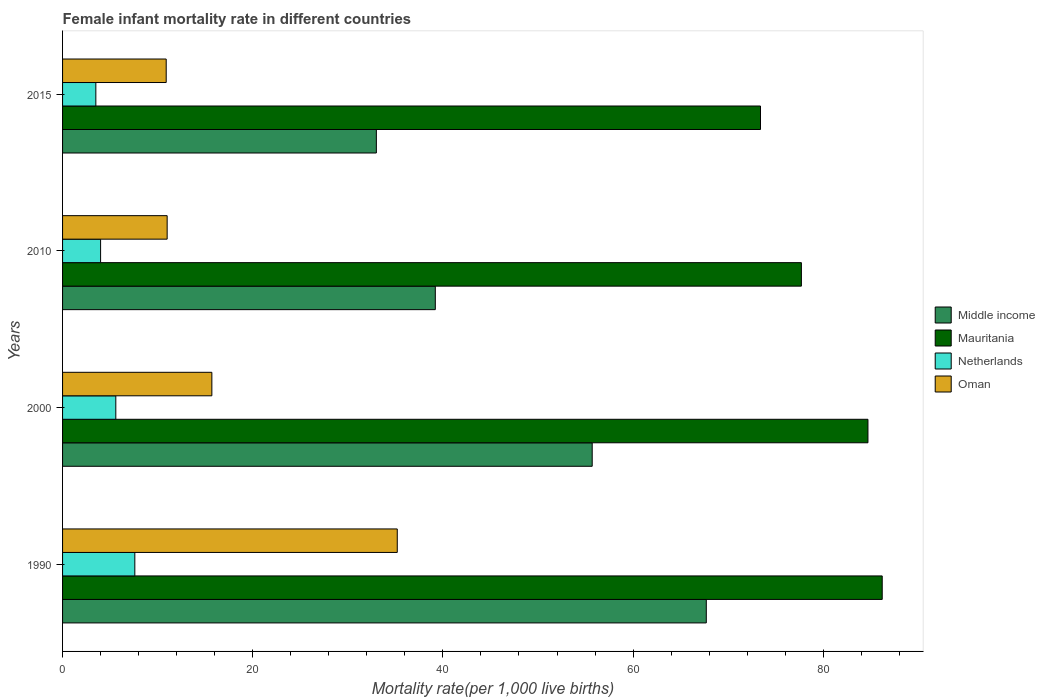How many different coloured bars are there?
Give a very brief answer. 4. How many groups of bars are there?
Your answer should be very brief. 4. Are the number of bars per tick equal to the number of legend labels?
Your answer should be very brief. Yes. Are the number of bars on each tick of the Y-axis equal?
Make the answer very short. Yes. How many bars are there on the 2nd tick from the bottom?
Make the answer very short. 4. Across all years, what is the minimum female infant mortality rate in Mauritania?
Provide a short and direct response. 73.4. In which year was the female infant mortality rate in Oman maximum?
Make the answer very short. 1990. In which year was the female infant mortality rate in Oman minimum?
Provide a short and direct response. 2015. What is the total female infant mortality rate in Netherlands in the graph?
Make the answer very short. 20.7. What is the difference between the female infant mortality rate in Middle income in 2010 and that in 2015?
Offer a very short reply. 6.2. What is the difference between the female infant mortality rate in Oman in 1990 and the female infant mortality rate in Netherlands in 2000?
Keep it short and to the point. 29.6. What is the average female infant mortality rate in Netherlands per year?
Provide a succinct answer. 5.17. In the year 2010, what is the difference between the female infant mortality rate in Oman and female infant mortality rate in Mauritania?
Provide a short and direct response. -66.7. What is the ratio of the female infant mortality rate in Netherlands in 1990 to that in 2010?
Your answer should be compact. 1.9. Is the female infant mortality rate in Mauritania in 1990 less than that in 2000?
Your response must be concise. No. Is the difference between the female infant mortality rate in Oman in 2000 and 2015 greater than the difference between the female infant mortality rate in Mauritania in 2000 and 2015?
Provide a short and direct response. No. What is the difference between the highest and the lowest female infant mortality rate in Middle income?
Give a very brief answer. 34.7. In how many years, is the female infant mortality rate in Netherlands greater than the average female infant mortality rate in Netherlands taken over all years?
Make the answer very short. 2. What does the 4th bar from the top in 2015 represents?
Provide a succinct answer. Middle income. What does the 2nd bar from the bottom in 1990 represents?
Ensure brevity in your answer.  Mauritania. Is it the case that in every year, the sum of the female infant mortality rate in Netherlands and female infant mortality rate in Middle income is greater than the female infant mortality rate in Mauritania?
Make the answer very short. No. How many years are there in the graph?
Your answer should be very brief. 4. What is the difference between two consecutive major ticks on the X-axis?
Your answer should be very brief. 20. Does the graph contain any zero values?
Make the answer very short. No. Does the graph contain grids?
Offer a terse response. No. Where does the legend appear in the graph?
Offer a terse response. Center right. How many legend labels are there?
Make the answer very short. 4. What is the title of the graph?
Offer a very short reply. Female infant mortality rate in different countries. Does "Sub-Saharan Africa (developing only)" appear as one of the legend labels in the graph?
Make the answer very short. No. What is the label or title of the X-axis?
Keep it short and to the point. Mortality rate(per 1,0 live births). What is the Mortality rate(per 1,000 live births) of Middle income in 1990?
Your answer should be very brief. 67.7. What is the Mortality rate(per 1,000 live births) of Mauritania in 1990?
Give a very brief answer. 86.2. What is the Mortality rate(per 1,000 live births) in Netherlands in 1990?
Your answer should be compact. 7.6. What is the Mortality rate(per 1,000 live births) of Oman in 1990?
Offer a terse response. 35.2. What is the Mortality rate(per 1,000 live births) in Middle income in 2000?
Your response must be concise. 55.7. What is the Mortality rate(per 1,000 live births) of Mauritania in 2000?
Make the answer very short. 84.7. What is the Mortality rate(per 1,000 live births) in Oman in 2000?
Your answer should be compact. 15.7. What is the Mortality rate(per 1,000 live births) of Middle income in 2010?
Give a very brief answer. 39.2. What is the Mortality rate(per 1,000 live births) of Mauritania in 2010?
Offer a very short reply. 77.7. What is the Mortality rate(per 1,000 live births) in Netherlands in 2010?
Make the answer very short. 4. What is the Mortality rate(per 1,000 live births) in Mauritania in 2015?
Provide a short and direct response. 73.4. What is the Mortality rate(per 1,000 live births) in Oman in 2015?
Ensure brevity in your answer.  10.9. Across all years, what is the maximum Mortality rate(per 1,000 live births) of Middle income?
Offer a terse response. 67.7. Across all years, what is the maximum Mortality rate(per 1,000 live births) of Mauritania?
Give a very brief answer. 86.2. Across all years, what is the maximum Mortality rate(per 1,000 live births) of Netherlands?
Provide a succinct answer. 7.6. Across all years, what is the maximum Mortality rate(per 1,000 live births) in Oman?
Offer a terse response. 35.2. Across all years, what is the minimum Mortality rate(per 1,000 live births) of Middle income?
Keep it short and to the point. 33. Across all years, what is the minimum Mortality rate(per 1,000 live births) of Mauritania?
Provide a succinct answer. 73.4. What is the total Mortality rate(per 1,000 live births) in Middle income in the graph?
Give a very brief answer. 195.6. What is the total Mortality rate(per 1,000 live births) in Mauritania in the graph?
Offer a terse response. 322. What is the total Mortality rate(per 1,000 live births) in Netherlands in the graph?
Offer a very short reply. 20.7. What is the total Mortality rate(per 1,000 live births) of Oman in the graph?
Provide a succinct answer. 72.8. What is the difference between the Mortality rate(per 1,000 live births) of Oman in 1990 and that in 2000?
Your answer should be very brief. 19.5. What is the difference between the Mortality rate(per 1,000 live births) of Oman in 1990 and that in 2010?
Give a very brief answer. 24.2. What is the difference between the Mortality rate(per 1,000 live births) in Middle income in 1990 and that in 2015?
Ensure brevity in your answer.  34.7. What is the difference between the Mortality rate(per 1,000 live births) of Mauritania in 1990 and that in 2015?
Provide a succinct answer. 12.8. What is the difference between the Mortality rate(per 1,000 live births) of Netherlands in 1990 and that in 2015?
Keep it short and to the point. 4.1. What is the difference between the Mortality rate(per 1,000 live births) in Oman in 1990 and that in 2015?
Provide a short and direct response. 24.3. What is the difference between the Mortality rate(per 1,000 live births) in Middle income in 2000 and that in 2010?
Offer a terse response. 16.5. What is the difference between the Mortality rate(per 1,000 live births) in Netherlands in 2000 and that in 2010?
Give a very brief answer. 1.6. What is the difference between the Mortality rate(per 1,000 live births) of Oman in 2000 and that in 2010?
Provide a short and direct response. 4.7. What is the difference between the Mortality rate(per 1,000 live births) in Middle income in 2000 and that in 2015?
Ensure brevity in your answer.  22.7. What is the difference between the Mortality rate(per 1,000 live births) in Mauritania in 2000 and that in 2015?
Ensure brevity in your answer.  11.3. What is the difference between the Mortality rate(per 1,000 live births) in Middle income in 2010 and that in 2015?
Keep it short and to the point. 6.2. What is the difference between the Mortality rate(per 1,000 live births) in Mauritania in 2010 and that in 2015?
Give a very brief answer. 4.3. What is the difference between the Mortality rate(per 1,000 live births) in Oman in 2010 and that in 2015?
Provide a short and direct response. 0.1. What is the difference between the Mortality rate(per 1,000 live births) in Middle income in 1990 and the Mortality rate(per 1,000 live births) in Mauritania in 2000?
Keep it short and to the point. -17. What is the difference between the Mortality rate(per 1,000 live births) of Middle income in 1990 and the Mortality rate(per 1,000 live births) of Netherlands in 2000?
Ensure brevity in your answer.  62.1. What is the difference between the Mortality rate(per 1,000 live births) of Mauritania in 1990 and the Mortality rate(per 1,000 live births) of Netherlands in 2000?
Offer a very short reply. 80.6. What is the difference between the Mortality rate(per 1,000 live births) of Mauritania in 1990 and the Mortality rate(per 1,000 live births) of Oman in 2000?
Offer a terse response. 70.5. What is the difference between the Mortality rate(per 1,000 live births) of Middle income in 1990 and the Mortality rate(per 1,000 live births) of Mauritania in 2010?
Your answer should be very brief. -10. What is the difference between the Mortality rate(per 1,000 live births) of Middle income in 1990 and the Mortality rate(per 1,000 live births) of Netherlands in 2010?
Provide a succinct answer. 63.7. What is the difference between the Mortality rate(per 1,000 live births) in Middle income in 1990 and the Mortality rate(per 1,000 live births) in Oman in 2010?
Keep it short and to the point. 56.7. What is the difference between the Mortality rate(per 1,000 live births) of Mauritania in 1990 and the Mortality rate(per 1,000 live births) of Netherlands in 2010?
Offer a very short reply. 82.2. What is the difference between the Mortality rate(per 1,000 live births) in Mauritania in 1990 and the Mortality rate(per 1,000 live births) in Oman in 2010?
Ensure brevity in your answer.  75.2. What is the difference between the Mortality rate(per 1,000 live births) in Middle income in 1990 and the Mortality rate(per 1,000 live births) in Mauritania in 2015?
Your response must be concise. -5.7. What is the difference between the Mortality rate(per 1,000 live births) of Middle income in 1990 and the Mortality rate(per 1,000 live births) of Netherlands in 2015?
Offer a terse response. 64.2. What is the difference between the Mortality rate(per 1,000 live births) of Middle income in 1990 and the Mortality rate(per 1,000 live births) of Oman in 2015?
Give a very brief answer. 56.8. What is the difference between the Mortality rate(per 1,000 live births) of Mauritania in 1990 and the Mortality rate(per 1,000 live births) of Netherlands in 2015?
Give a very brief answer. 82.7. What is the difference between the Mortality rate(per 1,000 live births) of Mauritania in 1990 and the Mortality rate(per 1,000 live births) of Oman in 2015?
Your answer should be very brief. 75.3. What is the difference between the Mortality rate(per 1,000 live births) in Middle income in 2000 and the Mortality rate(per 1,000 live births) in Netherlands in 2010?
Your answer should be very brief. 51.7. What is the difference between the Mortality rate(per 1,000 live births) in Middle income in 2000 and the Mortality rate(per 1,000 live births) in Oman in 2010?
Your answer should be compact. 44.7. What is the difference between the Mortality rate(per 1,000 live births) in Mauritania in 2000 and the Mortality rate(per 1,000 live births) in Netherlands in 2010?
Provide a short and direct response. 80.7. What is the difference between the Mortality rate(per 1,000 live births) in Mauritania in 2000 and the Mortality rate(per 1,000 live births) in Oman in 2010?
Ensure brevity in your answer.  73.7. What is the difference between the Mortality rate(per 1,000 live births) in Netherlands in 2000 and the Mortality rate(per 1,000 live births) in Oman in 2010?
Your response must be concise. -5.4. What is the difference between the Mortality rate(per 1,000 live births) of Middle income in 2000 and the Mortality rate(per 1,000 live births) of Mauritania in 2015?
Keep it short and to the point. -17.7. What is the difference between the Mortality rate(per 1,000 live births) of Middle income in 2000 and the Mortality rate(per 1,000 live births) of Netherlands in 2015?
Give a very brief answer. 52.2. What is the difference between the Mortality rate(per 1,000 live births) of Middle income in 2000 and the Mortality rate(per 1,000 live births) of Oman in 2015?
Ensure brevity in your answer.  44.8. What is the difference between the Mortality rate(per 1,000 live births) of Mauritania in 2000 and the Mortality rate(per 1,000 live births) of Netherlands in 2015?
Provide a succinct answer. 81.2. What is the difference between the Mortality rate(per 1,000 live births) of Mauritania in 2000 and the Mortality rate(per 1,000 live births) of Oman in 2015?
Provide a short and direct response. 73.8. What is the difference between the Mortality rate(per 1,000 live births) in Middle income in 2010 and the Mortality rate(per 1,000 live births) in Mauritania in 2015?
Your answer should be compact. -34.2. What is the difference between the Mortality rate(per 1,000 live births) of Middle income in 2010 and the Mortality rate(per 1,000 live births) of Netherlands in 2015?
Your answer should be very brief. 35.7. What is the difference between the Mortality rate(per 1,000 live births) in Middle income in 2010 and the Mortality rate(per 1,000 live births) in Oman in 2015?
Give a very brief answer. 28.3. What is the difference between the Mortality rate(per 1,000 live births) in Mauritania in 2010 and the Mortality rate(per 1,000 live births) in Netherlands in 2015?
Offer a very short reply. 74.2. What is the difference between the Mortality rate(per 1,000 live births) of Mauritania in 2010 and the Mortality rate(per 1,000 live births) of Oman in 2015?
Offer a very short reply. 66.8. What is the difference between the Mortality rate(per 1,000 live births) of Netherlands in 2010 and the Mortality rate(per 1,000 live births) of Oman in 2015?
Keep it short and to the point. -6.9. What is the average Mortality rate(per 1,000 live births) of Middle income per year?
Keep it short and to the point. 48.9. What is the average Mortality rate(per 1,000 live births) in Mauritania per year?
Offer a terse response. 80.5. What is the average Mortality rate(per 1,000 live births) of Netherlands per year?
Your answer should be compact. 5.17. What is the average Mortality rate(per 1,000 live births) of Oman per year?
Keep it short and to the point. 18.2. In the year 1990, what is the difference between the Mortality rate(per 1,000 live births) in Middle income and Mortality rate(per 1,000 live births) in Mauritania?
Keep it short and to the point. -18.5. In the year 1990, what is the difference between the Mortality rate(per 1,000 live births) in Middle income and Mortality rate(per 1,000 live births) in Netherlands?
Offer a very short reply. 60.1. In the year 1990, what is the difference between the Mortality rate(per 1,000 live births) of Middle income and Mortality rate(per 1,000 live births) of Oman?
Provide a short and direct response. 32.5. In the year 1990, what is the difference between the Mortality rate(per 1,000 live births) in Mauritania and Mortality rate(per 1,000 live births) in Netherlands?
Ensure brevity in your answer.  78.6. In the year 1990, what is the difference between the Mortality rate(per 1,000 live births) of Netherlands and Mortality rate(per 1,000 live births) of Oman?
Offer a terse response. -27.6. In the year 2000, what is the difference between the Mortality rate(per 1,000 live births) of Middle income and Mortality rate(per 1,000 live births) of Mauritania?
Your answer should be compact. -29. In the year 2000, what is the difference between the Mortality rate(per 1,000 live births) in Middle income and Mortality rate(per 1,000 live births) in Netherlands?
Offer a terse response. 50.1. In the year 2000, what is the difference between the Mortality rate(per 1,000 live births) in Mauritania and Mortality rate(per 1,000 live births) in Netherlands?
Your answer should be very brief. 79.1. In the year 2000, what is the difference between the Mortality rate(per 1,000 live births) of Mauritania and Mortality rate(per 1,000 live births) of Oman?
Offer a terse response. 69. In the year 2000, what is the difference between the Mortality rate(per 1,000 live births) of Netherlands and Mortality rate(per 1,000 live births) of Oman?
Give a very brief answer. -10.1. In the year 2010, what is the difference between the Mortality rate(per 1,000 live births) of Middle income and Mortality rate(per 1,000 live births) of Mauritania?
Your response must be concise. -38.5. In the year 2010, what is the difference between the Mortality rate(per 1,000 live births) in Middle income and Mortality rate(per 1,000 live births) in Netherlands?
Keep it short and to the point. 35.2. In the year 2010, what is the difference between the Mortality rate(per 1,000 live births) in Middle income and Mortality rate(per 1,000 live births) in Oman?
Your answer should be compact. 28.2. In the year 2010, what is the difference between the Mortality rate(per 1,000 live births) in Mauritania and Mortality rate(per 1,000 live births) in Netherlands?
Keep it short and to the point. 73.7. In the year 2010, what is the difference between the Mortality rate(per 1,000 live births) of Mauritania and Mortality rate(per 1,000 live births) of Oman?
Your response must be concise. 66.7. In the year 2015, what is the difference between the Mortality rate(per 1,000 live births) in Middle income and Mortality rate(per 1,000 live births) in Mauritania?
Make the answer very short. -40.4. In the year 2015, what is the difference between the Mortality rate(per 1,000 live births) in Middle income and Mortality rate(per 1,000 live births) in Netherlands?
Ensure brevity in your answer.  29.5. In the year 2015, what is the difference between the Mortality rate(per 1,000 live births) in Middle income and Mortality rate(per 1,000 live births) in Oman?
Give a very brief answer. 22.1. In the year 2015, what is the difference between the Mortality rate(per 1,000 live births) of Mauritania and Mortality rate(per 1,000 live births) of Netherlands?
Make the answer very short. 69.9. In the year 2015, what is the difference between the Mortality rate(per 1,000 live births) in Mauritania and Mortality rate(per 1,000 live births) in Oman?
Offer a very short reply. 62.5. What is the ratio of the Mortality rate(per 1,000 live births) in Middle income in 1990 to that in 2000?
Provide a succinct answer. 1.22. What is the ratio of the Mortality rate(per 1,000 live births) in Mauritania in 1990 to that in 2000?
Provide a succinct answer. 1.02. What is the ratio of the Mortality rate(per 1,000 live births) in Netherlands in 1990 to that in 2000?
Offer a terse response. 1.36. What is the ratio of the Mortality rate(per 1,000 live births) in Oman in 1990 to that in 2000?
Provide a short and direct response. 2.24. What is the ratio of the Mortality rate(per 1,000 live births) in Middle income in 1990 to that in 2010?
Your answer should be compact. 1.73. What is the ratio of the Mortality rate(per 1,000 live births) of Mauritania in 1990 to that in 2010?
Your answer should be very brief. 1.11. What is the ratio of the Mortality rate(per 1,000 live births) in Middle income in 1990 to that in 2015?
Ensure brevity in your answer.  2.05. What is the ratio of the Mortality rate(per 1,000 live births) in Mauritania in 1990 to that in 2015?
Offer a terse response. 1.17. What is the ratio of the Mortality rate(per 1,000 live births) of Netherlands in 1990 to that in 2015?
Ensure brevity in your answer.  2.17. What is the ratio of the Mortality rate(per 1,000 live births) in Oman in 1990 to that in 2015?
Keep it short and to the point. 3.23. What is the ratio of the Mortality rate(per 1,000 live births) of Middle income in 2000 to that in 2010?
Offer a terse response. 1.42. What is the ratio of the Mortality rate(per 1,000 live births) in Mauritania in 2000 to that in 2010?
Ensure brevity in your answer.  1.09. What is the ratio of the Mortality rate(per 1,000 live births) in Netherlands in 2000 to that in 2010?
Offer a very short reply. 1.4. What is the ratio of the Mortality rate(per 1,000 live births) of Oman in 2000 to that in 2010?
Ensure brevity in your answer.  1.43. What is the ratio of the Mortality rate(per 1,000 live births) in Middle income in 2000 to that in 2015?
Your answer should be very brief. 1.69. What is the ratio of the Mortality rate(per 1,000 live births) in Mauritania in 2000 to that in 2015?
Give a very brief answer. 1.15. What is the ratio of the Mortality rate(per 1,000 live births) of Oman in 2000 to that in 2015?
Offer a terse response. 1.44. What is the ratio of the Mortality rate(per 1,000 live births) of Middle income in 2010 to that in 2015?
Make the answer very short. 1.19. What is the ratio of the Mortality rate(per 1,000 live births) in Mauritania in 2010 to that in 2015?
Give a very brief answer. 1.06. What is the ratio of the Mortality rate(per 1,000 live births) of Netherlands in 2010 to that in 2015?
Provide a short and direct response. 1.14. What is the ratio of the Mortality rate(per 1,000 live births) of Oman in 2010 to that in 2015?
Keep it short and to the point. 1.01. What is the difference between the highest and the second highest Mortality rate(per 1,000 live births) of Middle income?
Your answer should be compact. 12. What is the difference between the highest and the second highest Mortality rate(per 1,000 live births) of Oman?
Give a very brief answer. 19.5. What is the difference between the highest and the lowest Mortality rate(per 1,000 live births) in Middle income?
Make the answer very short. 34.7. What is the difference between the highest and the lowest Mortality rate(per 1,000 live births) in Netherlands?
Your answer should be compact. 4.1. What is the difference between the highest and the lowest Mortality rate(per 1,000 live births) of Oman?
Give a very brief answer. 24.3. 